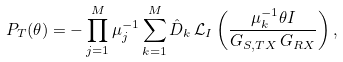<formula> <loc_0><loc_0><loc_500><loc_500>P _ { T } ( \theta ) = - \prod _ { j = 1 } ^ { M } \mu ^ { - 1 } _ { j } \sum _ { k = 1 } ^ { M } \hat { D } _ { k } \, \mathcal { L } _ { I } \left ( \frac { \mu _ { k } ^ { - 1 } \theta I } { G _ { S , T X } \, G _ { R X } } \right ) ,</formula> 